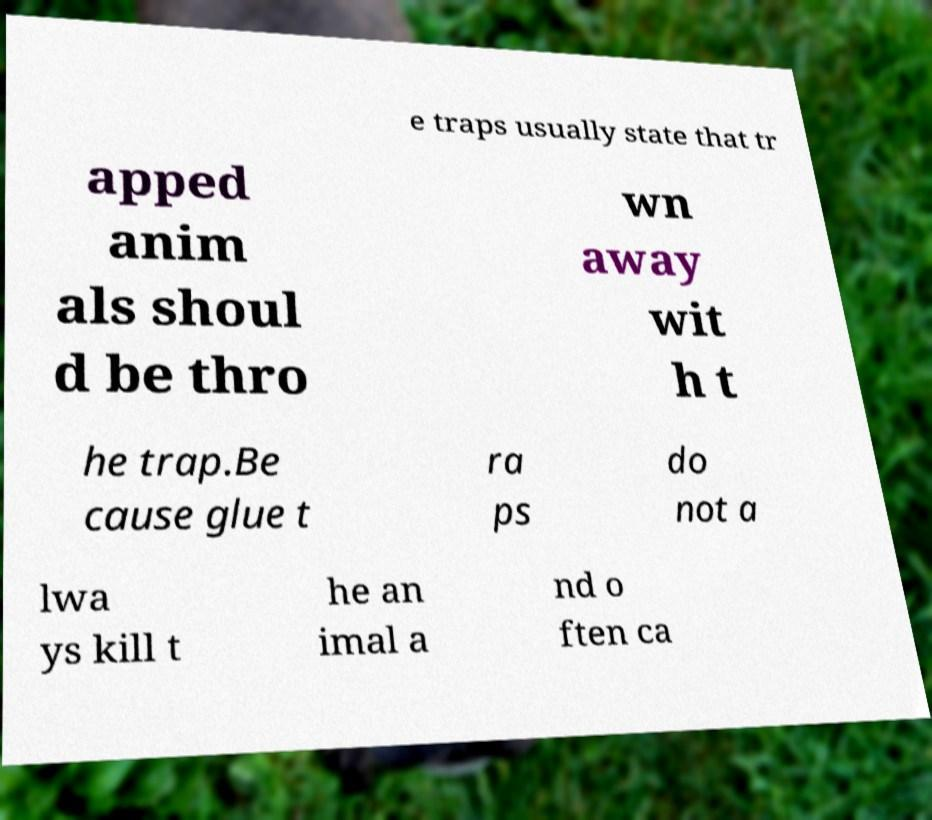Please read and relay the text visible in this image. What does it say? e traps usually state that tr apped anim als shoul d be thro wn away wit h t he trap.Be cause glue t ra ps do not a lwa ys kill t he an imal a nd o ften ca 